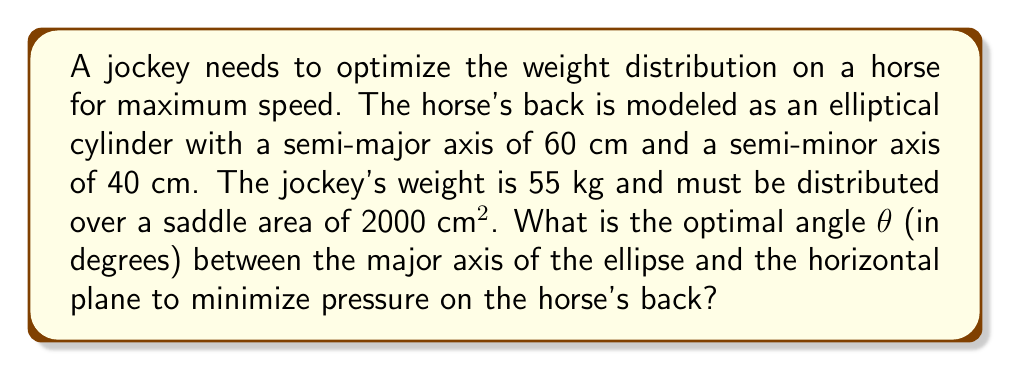Could you help me with this problem? To solve this problem, we'll follow these steps:

1) The pressure on the horse's back is given by $P = \frac{F}{A}$, where $F$ is the force (jockey's weight) and $A$ is the area of contact.

2) The area of contact depends on the angle θ. We need to find the angle that maximizes this area, which will minimize the pressure.

3) The equation of the ellipse in parametric form is:
   $x = 60 \cos(t)$, $y = 40 \sin(t)$

4) When rotated by angle θ, the parametric equations become:
   $x' = 60 \cos(t) \cos(θ) - 40 \sin(t) \sin(θ)$
   $y' = 60 \cos(t) \sin(θ) + 40 \sin(t) \cos(θ)$

5) The area of contact is proportional to the projection of the ellipse onto the horizontal plane. This projection is itself an ellipse with semi-axes $a'$ and $b'$:

   $a' = \sqrt{(60 \cos(θ))^2 + (40 \sin(θ))^2}$
   $b' = 40 \cos(θ)$

6) The area of this projected ellipse is $A = π a' b'$. We want to maximize this:

   $A = π \sqrt{(60 \cos(θ))^2 + (40 \sin(θ))^2} (40 \cos(θ))$

7) To find the maximum, we differentiate $A$ with respect to θ and set it to zero:

   $\frac{dA}{dθ} = 0$

8) Solving this equation analytically is complex, so we use numerical methods.

9) The maximum occurs at approximately θ ≈ 33.69°

10) This angle maximizes the contact area and thus minimizes the pressure on the horse's back.
Answer: 33.69° 